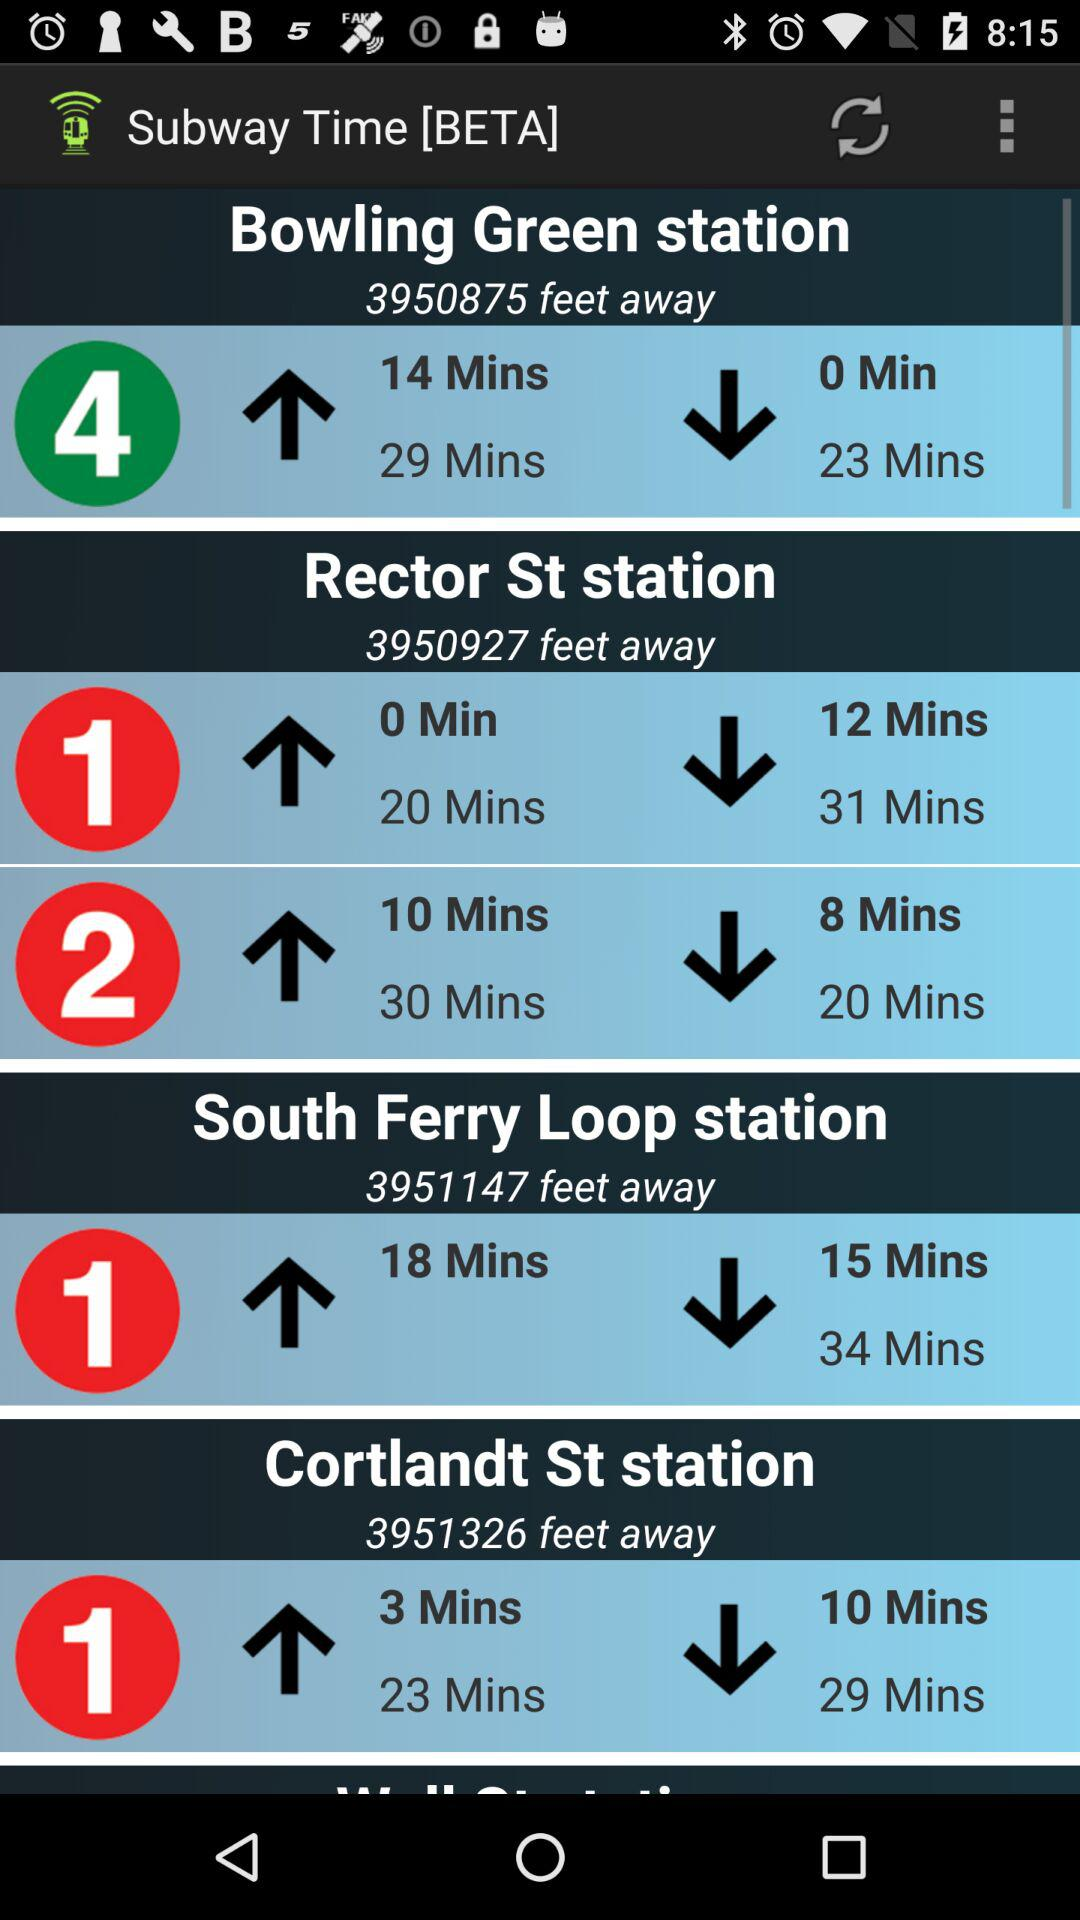What is the application name? The application name is "Subway Time [BETA]". 